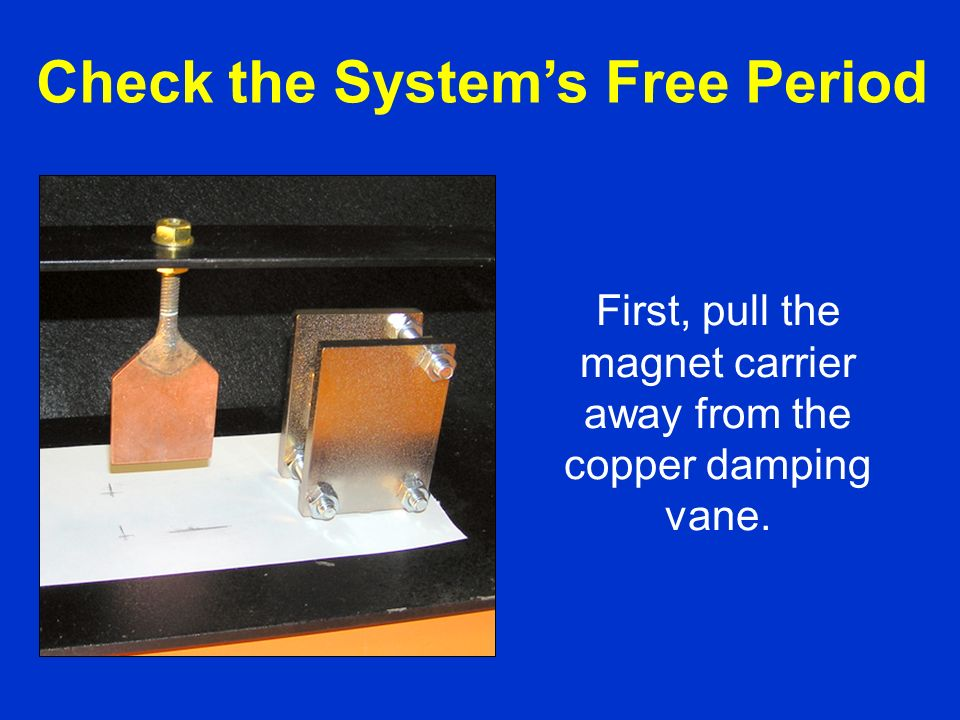What would it feel like if humans could sense magnetic fields directly? How would that change the way we interact with this setup? If humans could sense magnetic fields directly, it would profoundly alter our interaction with and perception of setups such as this one. Imagine being able to 'feel' the magnetic flux variations as the magnet moves away from the copper vane, allowing us to intuitively understand Lenz's Law at a sensory level. This ability might enable us to optimize experiments in real-time with heightened precision, adjusting variables instinctively based on magnetic feedback. The educational impact would be significant, as students and professionals could 'experience' electromagnetism first-hand rather than abstractly through formulas. Beyond the lab, sensing magnetic fields could revolutionize navigation, akin to a biological compass, enhancing spatial awareness in ways that are currently unimaginable, fostering advancements in fields ranging from medicine to augmented reality. Imagine walking through a forest and being able to 'feel' the magnetic interactions between natural minerals in the earth and the geomagnetic field, sensing the ebb and flow of invisible forces. This new sense would redefine our understanding of the environment and the universe, leading to breakthroughs in both theoretical and applied sciences. 